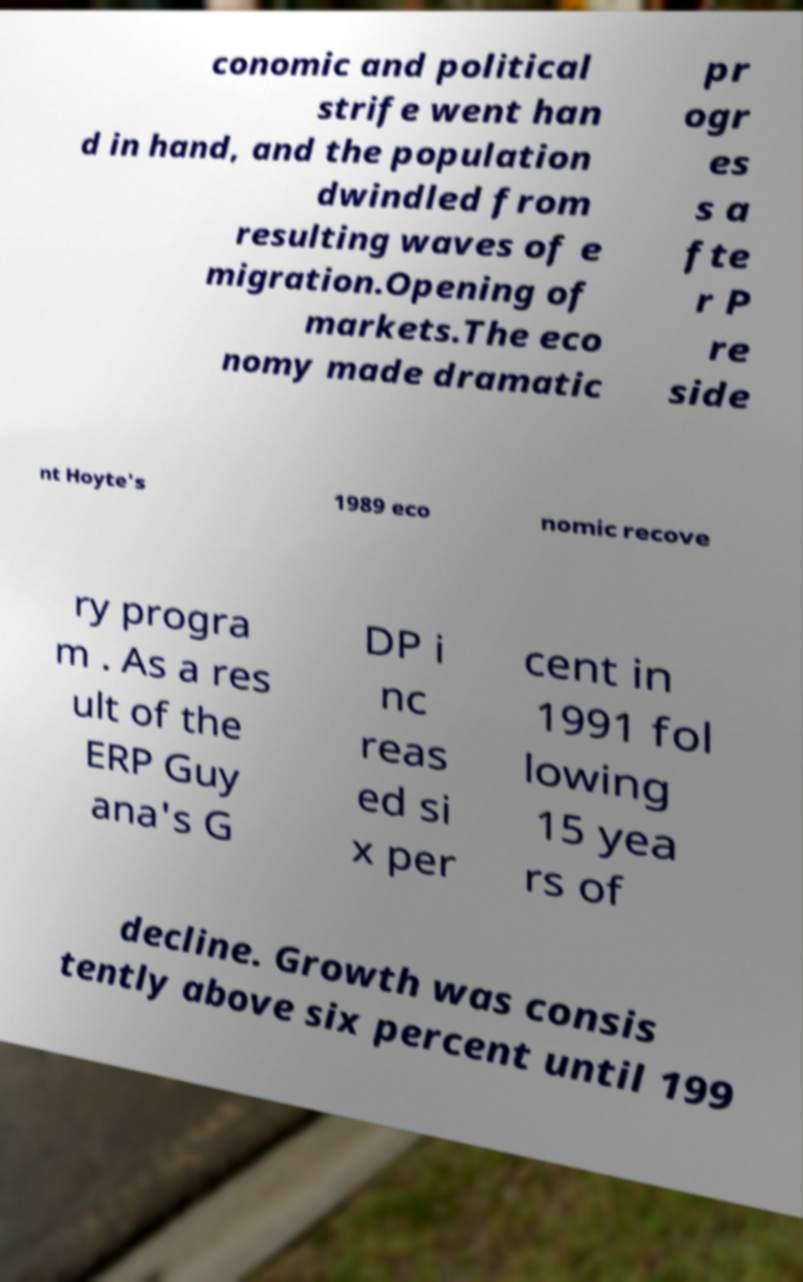There's text embedded in this image that I need extracted. Can you transcribe it verbatim? conomic and political strife went han d in hand, and the population dwindled from resulting waves of e migration.Opening of markets.The eco nomy made dramatic pr ogr es s a fte r P re side nt Hoyte's 1989 eco nomic recove ry progra m . As a res ult of the ERP Guy ana's G DP i nc reas ed si x per cent in 1991 fol lowing 15 yea rs of decline. Growth was consis tently above six percent until 199 